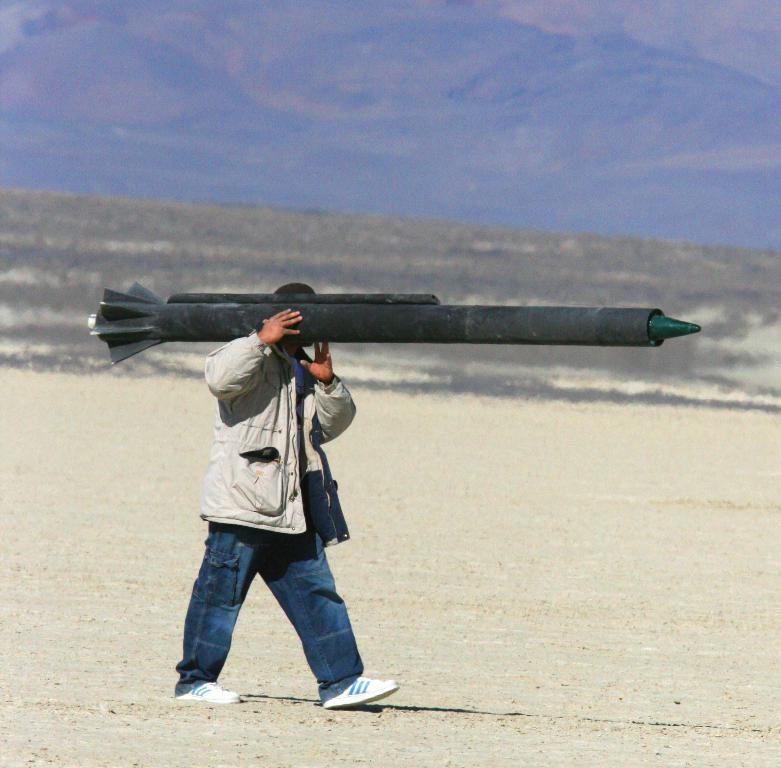What is the main subject of the image? There is a person in the image. What is the person holding in the image? The person is holding a weapon. Can you describe the background of the image? The background of the image is blurred. What type of scissors can be seen in the image? There are no scissors present in the image. Is the person in the image driving a vehicle? There is no indication of a vehicle or driving in the image. 